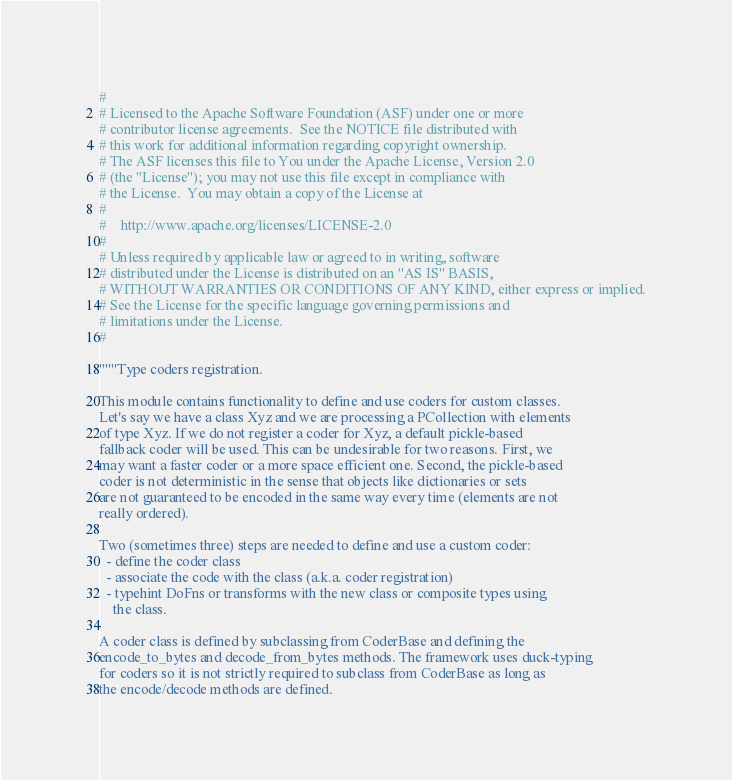Convert code to text. <code><loc_0><loc_0><loc_500><loc_500><_Python_>#
# Licensed to the Apache Software Foundation (ASF) under one or more
# contributor license agreements.  See the NOTICE file distributed with
# this work for additional information regarding copyright ownership.
# The ASF licenses this file to You under the Apache License, Version 2.0
# (the "License"); you may not use this file except in compliance with
# the License.  You may obtain a copy of the License at
#
#    http://www.apache.org/licenses/LICENSE-2.0
#
# Unless required by applicable law or agreed to in writing, software
# distributed under the License is distributed on an "AS IS" BASIS,
# WITHOUT WARRANTIES OR CONDITIONS OF ANY KIND, either express or implied.
# See the License for the specific language governing permissions and
# limitations under the License.
#

"""Type coders registration.

This module contains functionality to define and use coders for custom classes.
Let's say we have a class Xyz and we are processing a PCollection with elements
of type Xyz. If we do not register a coder for Xyz, a default pickle-based
fallback coder will be used. This can be undesirable for two reasons. First, we
may want a faster coder or a more space efficient one. Second, the pickle-based
coder is not deterministic in the sense that objects like dictionaries or sets
are not guaranteed to be encoded in the same way every time (elements are not
really ordered).

Two (sometimes three) steps are needed to define and use a custom coder:
  - define the coder class
  - associate the code with the class (a.k.a. coder registration)
  - typehint DoFns or transforms with the new class or composite types using
    the class.

A coder class is defined by subclassing from CoderBase and defining the
encode_to_bytes and decode_from_bytes methods. The framework uses duck-typing
for coders so it is not strictly required to subclass from CoderBase as long as
the encode/decode methods are defined.
</code> 